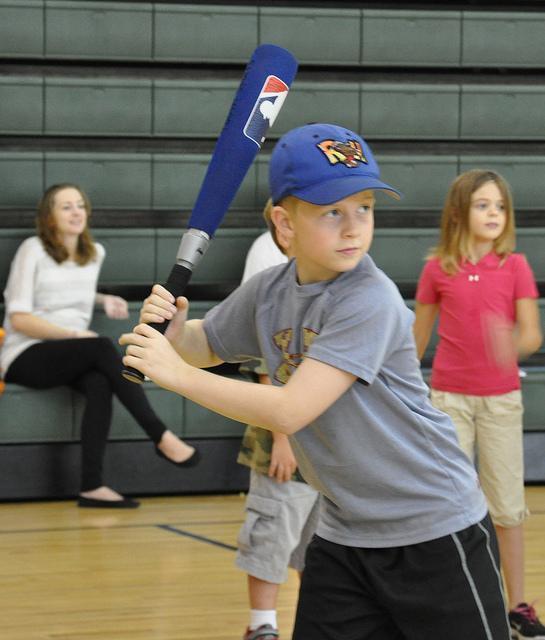How many people are visible?
Give a very brief answer. 4. 